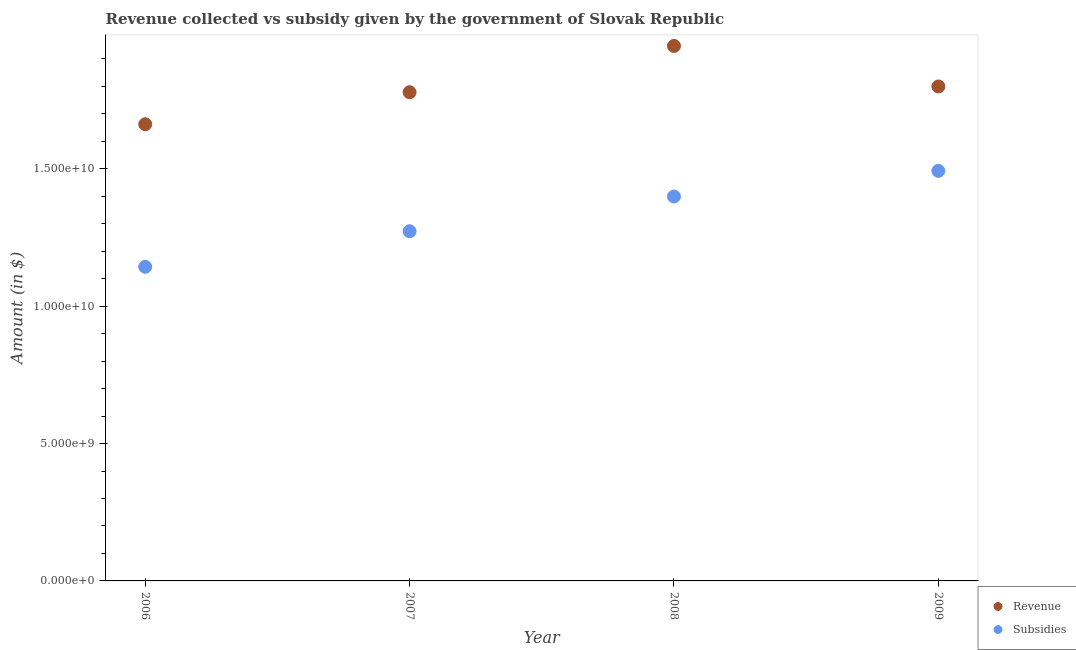How many different coloured dotlines are there?
Give a very brief answer. 2. What is the amount of revenue collected in 2009?
Offer a very short reply. 1.80e+1. Across all years, what is the maximum amount of subsidies given?
Provide a succinct answer. 1.49e+1. Across all years, what is the minimum amount of revenue collected?
Offer a terse response. 1.66e+1. In which year was the amount of subsidies given maximum?
Give a very brief answer. 2009. What is the total amount of subsidies given in the graph?
Offer a very short reply. 5.31e+1. What is the difference between the amount of subsidies given in 2006 and that in 2008?
Make the answer very short. -2.56e+09. What is the difference between the amount of subsidies given in 2006 and the amount of revenue collected in 2008?
Provide a succinct answer. -8.04e+09. What is the average amount of subsidies given per year?
Your response must be concise. 1.33e+1. In the year 2008, what is the difference between the amount of revenue collected and amount of subsidies given?
Provide a short and direct response. 5.48e+09. In how many years, is the amount of revenue collected greater than 3000000000 $?
Make the answer very short. 4. What is the ratio of the amount of subsidies given in 2006 to that in 2009?
Your response must be concise. 0.77. Is the difference between the amount of subsidies given in 2008 and 2009 greater than the difference between the amount of revenue collected in 2008 and 2009?
Your answer should be compact. No. What is the difference between the highest and the second highest amount of revenue collected?
Your response must be concise. 1.48e+09. What is the difference between the highest and the lowest amount of subsidies given?
Ensure brevity in your answer.  3.49e+09. Does the amount of revenue collected monotonically increase over the years?
Offer a very short reply. No. Is the amount of subsidies given strictly less than the amount of revenue collected over the years?
Provide a succinct answer. Yes. How many dotlines are there?
Offer a terse response. 2. What is the difference between two consecutive major ticks on the Y-axis?
Keep it short and to the point. 5.00e+09. Are the values on the major ticks of Y-axis written in scientific E-notation?
Offer a terse response. Yes. Does the graph contain any zero values?
Make the answer very short. No. Does the graph contain grids?
Give a very brief answer. No. Where does the legend appear in the graph?
Provide a succinct answer. Bottom right. What is the title of the graph?
Keep it short and to the point. Revenue collected vs subsidy given by the government of Slovak Republic. Does "Passenger Transport Items" appear as one of the legend labels in the graph?
Provide a short and direct response. No. What is the label or title of the X-axis?
Offer a terse response. Year. What is the label or title of the Y-axis?
Keep it short and to the point. Amount (in $). What is the Amount (in $) of Revenue in 2006?
Provide a short and direct response. 1.66e+1. What is the Amount (in $) in Subsidies in 2006?
Offer a terse response. 1.14e+1. What is the Amount (in $) of Revenue in 2007?
Provide a short and direct response. 1.78e+1. What is the Amount (in $) of Subsidies in 2007?
Keep it short and to the point. 1.27e+1. What is the Amount (in $) of Revenue in 2008?
Your answer should be very brief. 1.95e+1. What is the Amount (in $) of Subsidies in 2008?
Make the answer very short. 1.40e+1. What is the Amount (in $) in Revenue in 2009?
Offer a very short reply. 1.80e+1. What is the Amount (in $) of Subsidies in 2009?
Ensure brevity in your answer.  1.49e+1. Across all years, what is the maximum Amount (in $) of Revenue?
Offer a very short reply. 1.95e+1. Across all years, what is the maximum Amount (in $) in Subsidies?
Your answer should be compact. 1.49e+1. Across all years, what is the minimum Amount (in $) of Revenue?
Your answer should be very brief. 1.66e+1. Across all years, what is the minimum Amount (in $) in Subsidies?
Provide a succinct answer. 1.14e+1. What is the total Amount (in $) in Revenue in the graph?
Your answer should be very brief. 7.19e+1. What is the total Amount (in $) in Subsidies in the graph?
Offer a terse response. 5.31e+1. What is the difference between the Amount (in $) of Revenue in 2006 and that in 2007?
Offer a terse response. -1.17e+09. What is the difference between the Amount (in $) of Subsidies in 2006 and that in 2007?
Offer a terse response. -1.29e+09. What is the difference between the Amount (in $) of Revenue in 2006 and that in 2008?
Provide a short and direct response. -2.85e+09. What is the difference between the Amount (in $) of Subsidies in 2006 and that in 2008?
Keep it short and to the point. -2.56e+09. What is the difference between the Amount (in $) of Revenue in 2006 and that in 2009?
Your response must be concise. -1.38e+09. What is the difference between the Amount (in $) in Subsidies in 2006 and that in 2009?
Your answer should be compact. -3.49e+09. What is the difference between the Amount (in $) in Revenue in 2007 and that in 2008?
Offer a terse response. -1.69e+09. What is the difference between the Amount (in $) in Subsidies in 2007 and that in 2008?
Keep it short and to the point. -1.26e+09. What is the difference between the Amount (in $) of Revenue in 2007 and that in 2009?
Your answer should be very brief. -2.09e+08. What is the difference between the Amount (in $) in Subsidies in 2007 and that in 2009?
Provide a short and direct response. -2.20e+09. What is the difference between the Amount (in $) in Revenue in 2008 and that in 2009?
Offer a terse response. 1.48e+09. What is the difference between the Amount (in $) in Subsidies in 2008 and that in 2009?
Your response must be concise. -9.33e+08. What is the difference between the Amount (in $) in Revenue in 2006 and the Amount (in $) in Subsidies in 2007?
Offer a terse response. 3.89e+09. What is the difference between the Amount (in $) of Revenue in 2006 and the Amount (in $) of Subsidies in 2008?
Give a very brief answer. 2.63e+09. What is the difference between the Amount (in $) of Revenue in 2006 and the Amount (in $) of Subsidies in 2009?
Make the answer very short. 1.70e+09. What is the difference between the Amount (in $) of Revenue in 2007 and the Amount (in $) of Subsidies in 2008?
Give a very brief answer. 3.80e+09. What is the difference between the Amount (in $) in Revenue in 2007 and the Amount (in $) in Subsidies in 2009?
Offer a terse response. 2.86e+09. What is the difference between the Amount (in $) of Revenue in 2008 and the Amount (in $) of Subsidies in 2009?
Your answer should be compact. 4.55e+09. What is the average Amount (in $) in Revenue per year?
Your answer should be compact. 1.80e+1. What is the average Amount (in $) of Subsidies per year?
Your answer should be compact. 1.33e+1. In the year 2006, what is the difference between the Amount (in $) in Revenue and Amount (in $) in Subsidies?
Give a very brief answer. 5.19e+09. In the year 2007, what is the difference between the Amount (in $) in Revenue and Amount (in $) in Subsidies?
Ensure brevity in your answer.  5.06e+09. In the year 2008, what is the difference between the Amount (in $) in Revenue and Amount (in $) in Subsidies?
Keep it short and to the point. 5.48e+09. In the year 2009, what is the difference between the Amount (in $) in Revenue and Amount (in $) in Subsidies?
Keep it short and to the point. 3.07e+09. What is the ratio of the Amount (in $) of Revenue in 2006 to that in 2007?
Offer a terse response. 0.93. What is the ratio of the Amount (in $) in Subsidies in 2006 to that in 2007?
Offer a very short reply. 0.9. What is the ratio of the Amount (in $) in Revenue in 2006 to that in 2008?
Offer a very short reply. 0.85. What is the ratio of the Amount (in $) in Subsidies in 2006 to that in 2008?
Offer a terse response. 0.82. What is the ratio of the Amount (in $) in Revenue in 2006 to that in 2009?
Provide a succinct answer. 0.92. What is the ratio of the Amount (in $) of Subsidies in 2006 to that in 2009?
Make the answer very short. 0.77. What is the ratio of the Amount (in $) of Revenue in 2007 to that in 2008?
Provide a short and direct response. 0.91. What is the ratio of the Amount (in $) in Subsidies in 2007 to that in 2008?
Offer a very short reply. 0.91. What is the ratio of the Amount (in $) in Revenue in 2007 to that in 2009?
Ensure brevity in your answer.  0.99. What is the ratio of the Amount (in $) of Subsidies in 2007 to that in 2009?
Give a very brief answer. 0.85. What is the ratio of the Amount (in $) in Revenue in 2008 to that in 2009?
Keep it short and to the point. 1.08. What is the ratio of the Amount (in $) in Subsidies in 2008 to that in 2009?
Your answer should be very brief. 0.94. What is the difference between the highest and the second highest Amount (in $) of Revenue?
Provide a short and direct response. 1.48e+09. What is the difference between the highest and the second highest Amount (in $) of Subsidies?
Give a very brief answer. 9.33e+08. What is the difference between the highest and the lowest Amount (in $) of Revenue?
Ensure brevity in your answer.  2.85e+09. What is the difference between the highest and the lowest Amount (in $) in Subsidies?
Your response must be concise. 3.49e+09. 